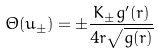Convert formula to latex. <formula><loc_0><loc_0><loc_500><loc_500>\Theta ( u _ { \pm } ) = \pm \frac { K _ { \pm } g ^ { \prime } ( r ) } { 4 r \sqrt { g ( r ) } }</formula> 